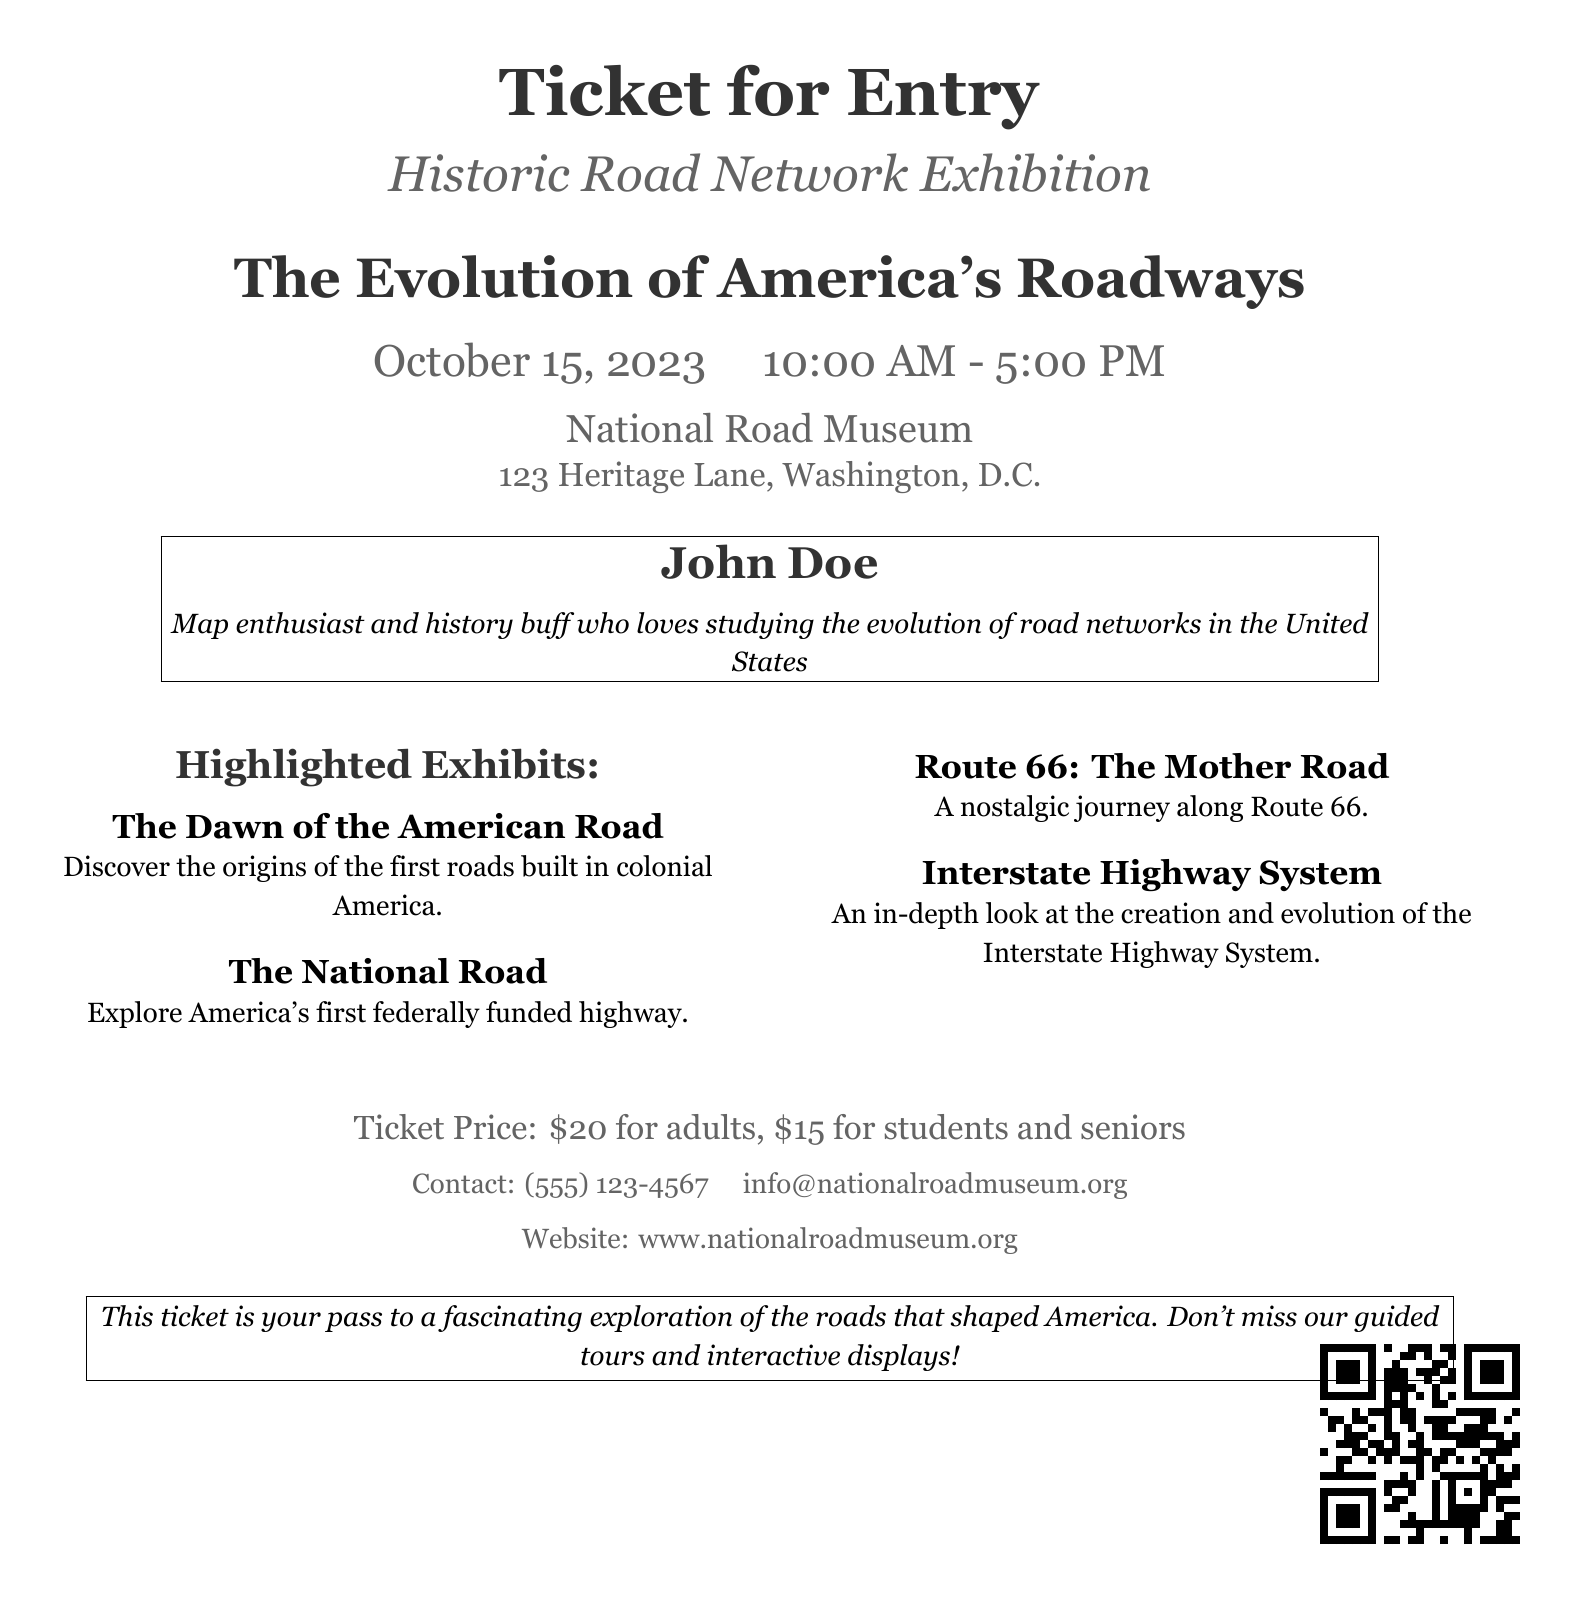What is the exhibit date? The exhibit date is explicitly stated in the document, which mentions "October 15, 2023."
Answer: October 15, 2023 What is the ticket price for adults? The document clearly indicates the ticket price for adults as "$20."
Answer: $20 What is the venue of the exhibition? The document specifies the location of the exhibition as "National Road Museum."
Answer: National Road Museum Who is the ticket holder? The ticket holder's name is presented in the document, which states "John Doe."
Answer: John Doe What are the exhibition hours? The document lists the exhibition hours as "10:00 AM - 5:00 PM."
Answer: 10:00 AM - 5:00 PM What is one of the highlighted exhibits? The document mentions several highlighted exhibits, one of which is "The National Road."
Answer: The National Road How much is the ticket price for students? The document states the ticket price for students as "$15."
Answer: $15 What is the contact phone number for inquiries? The document provides a contact phone number, which is listed as "(555) 123-4567."
Answer: (555) 123-4567 What is the website for more information? The document includes a website for further details, which is "www.nationalroadmuseum.org."
Answer: www.nationalroadmuseum.org 